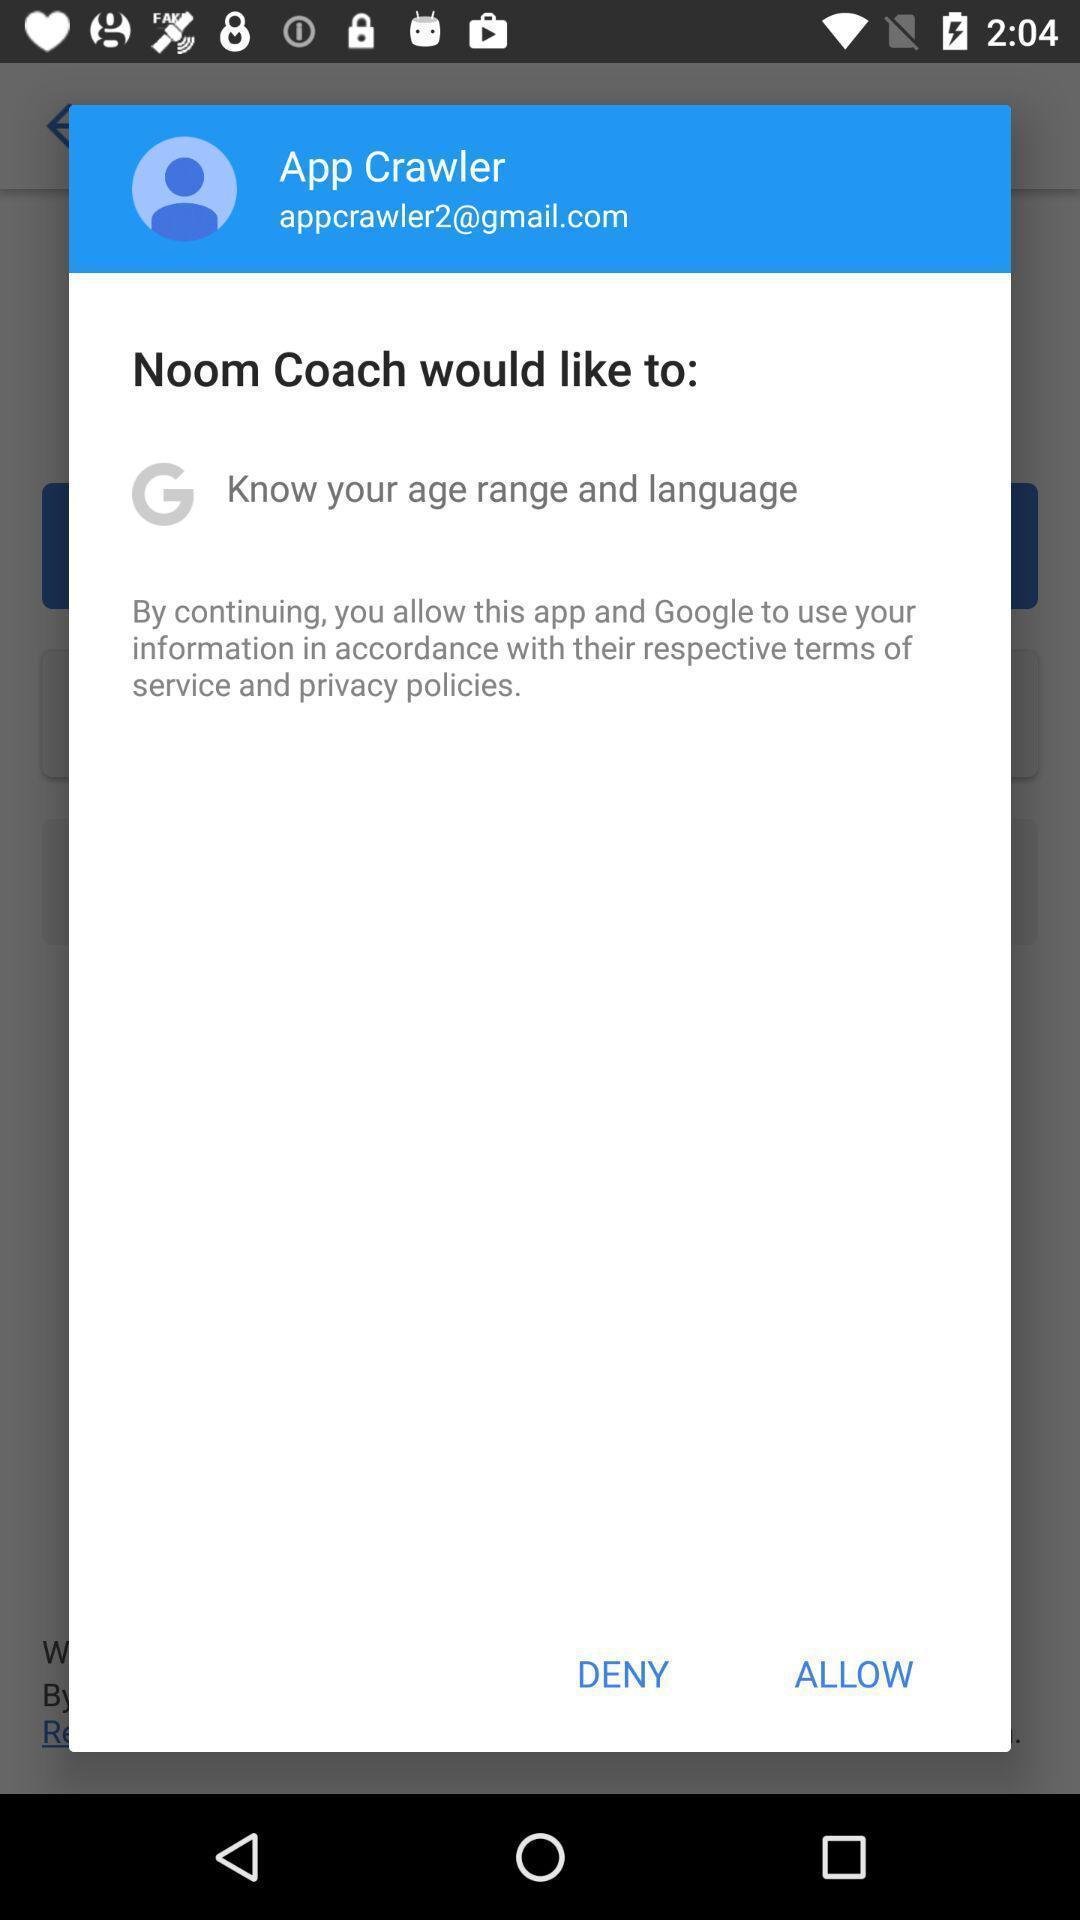Summarize the information in this screenshot. Pop-up shows allow to an application. 